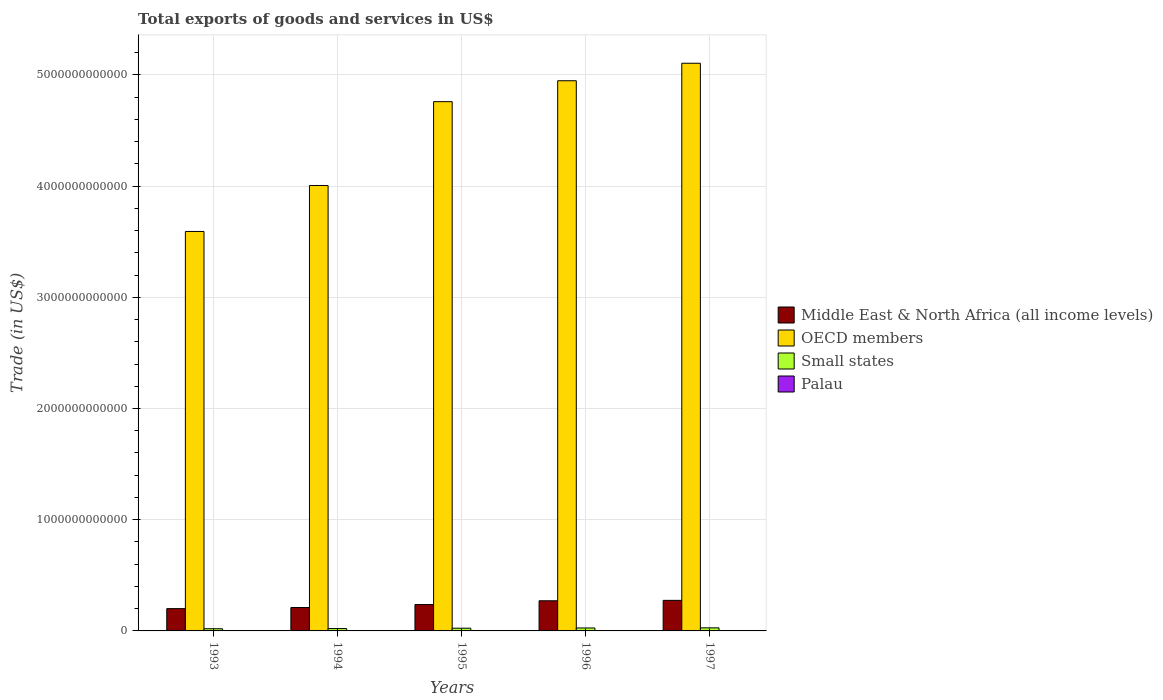How many different coloured bars are there?
Give a very brief answer. 4. How many groups of bars are there?
Your response must be concise. 5. Are the number of bars on each tick of the X-axis equal?
Ensure brevity in your answer.  Yes. How many bars are there on the 2nd tick from the left?
Keep it short and to the point. 4. How many bars are there on the 3rd tick from the right?
Keep it short and to the point. 4. What is the total exports of goods and services in Small states in 1995?
Your answer should be compact. 2.44e+1. Across all years, what is the maximum total exports of goods and services in OECD members?
Your answer should be compact. 5.10e+12. Across all years, what is the minimum total exports of goods and services in Small states?
Your response must be concise. 1.95e+1. In which year was the total exports of goods and services in Middle East & North Africa (all income levels) maximum?
Ensure brevity in your answer.  1997. In which year was the total exports of goods and services in Palau minimum?
Your answer should be very brief. 1997. What is the total total exports of goods and services in Middle East & North Africa (all income levels) in the graph?
Your answer should be compact. 1.19e+12. What is the difference between the total exports of goods and services in Middle East & North Africa (all income levels) in 1993 and that in 1997?
Give a very brief answer. -7.41e+1. What is the difference between the total exports of goods and services in Palau in 1993 and the total exports of goods and services in OECD members in 1997?
Your answer should be very brief. -5.10e+12. What is the average total exports of goods and services in OECD members per year?
Provide a short and direct response. 4.48e+12. In the year 1996, what is the difference between the total exports of goods and services in Palau and total exports of goods and services in Small states?
Provide a succinct answer. -2.64e+1. In how many years, is the total exports of goods and services in Small states greater than 3000000000000 US$?
Offer a very short reply. 0. What is the ratio of the total exports of goods and services in Middle East & North Africa (all income levels) in 1993 to that in 1997?
Keep it short and to the point. 0.73. Is the difference between the total exports of goods and services in Palau in 1994 and 1997 greater than the difference between the total exports of goods and services in Small states in 1994 and 1997?
Provide a succinct answer. Yes. What is the difference between the highest and the second highest total exports of goods and services in Middle East & North Africa (all income levels)?
Give a very brief answer. 3.57e+09. What is the difference between the highest and the lowest total exports of goods and services in Middle East & North Africa (all income levels)?
Give a very brief answer. 7.41e+1. What does the 3rd bar from the left in 1994 represents?
Keep it short and to the point. Small states. What does the 1st bar from the right in 1994 represents?
Your response must be concise. Palau. Is it the case that in every year, the sum of the total exports of goods and services in Palau and total exports of goods and services in OECD members is greater than the total exports of goods and services in Middle East & North Africa (all income levels)?
Make the answer very short. Yes. How many years are there in the graph?
Give a very brief answer. 5. What is the difference between two consecutive major ticks on the Y-axis?
Provide a succinct answer. 1.00e+12. Are the values on the major ticks of Y-axis written in scientific E-notation?
Your answer should be very brief. No. Does the graph contain any zero values?
Your answer should be very brief. No. Does the graph contain grids?
Your answer should be compact. Yes. How are the legend labels stacked?
Ensure brevity in your answer.  Vertical. What is the title of the graph?
Your answer should be compact. Total exports of goods and services in US$. What is the label or title of the X-axis?
Your answer should be very brief. Years. What is the label or title of the Y-axis?
Offer a very short reply. Trade (in US$). What is the Trade (in US$) of Middle East & North Africa (all income levels) in 1993?
Your response must be concise. 2.01e+11. What is the Trade (in US$) in OECD members in 1993?
Provide a succinct answer. 3.59e+12. What is the Trade (in US$) of Small states in 1993?
Offer a very short reply. 1.95e+1. What is the Trade (in US$) of Palau in 1993?
Your response must be concise. 1.77e+07. What is the Trade (in US$) of Middle East & North Africa (all income levels) in 1994?
Offer a terse response. 2.10e+11. What is the Trade (in US$) of OECD members in 1994?
Offer a very short reply. 4.00e+12. What is the Trade (in US$) in Small states in 1994?
Give a very brief answer. 2.12e+1. What is the Trade (in US$) in Palau in 1994?
Make the answer very short. 1.26e+07. What is the Trade (in US$) of Middle East & North Africa (all income levels) in 1995?
Offer a terse response. 2.37e+11. What is the Trade (in US$) of OECD members in 1995?
Provide a short and direct response. 4.76e+12. What is the Trade (in US$) in Small states in 1995?
Your response must be concise. 2.44e+1. What is the Trade (in US$) in Palau in 1995?
Your answer should be compact. 1.39e+07. What is the Trade (in US$) of Middle East & North Africa (all income levels) in 1996?
Provide a succinct answer. 2.71e+11. What is the Trade (in US$) of OECD members in 1996?
Keep it short and to the point. 4.95e+12. What is the Trade (in US$) of Small states in 1996?
Your answer should be very brief. 2.64e+1. What is the Trade (in US$) in Palau in 1996?
Offer a very short reply. 1.39e+07. What is the Trade (in US$) in Middle East & North Africa (all income levels) in 1997?
Offer a very short reply. 2.75e+11. What is the Trade (in US$) of OECD members in 1997?
Your answer should be very brief. 5.10e+12. What is the Trade (in US$) in Small states in 1997?
Your response must be concise. 2.76e+1. What is the Trade (in US$) of Palau in 1997?
Your answer should be very brief. 1.18e+07. Across all years, what is the maximum Trade (in US$) of Middle East & North Africa (all income levels)?
Provide a short and direct response. 2.75e+11. Across all years, what is the maximum Trade (in US$) in OECD members?
Give a very brief answer. 5.10e+12. Across all years, what is the maximum Trade (in US$) of Small states?
Provide a short and direct response. 2.76e+1. Across all years, what is the maximum Trade (in US$) of Palau?
Your answer should be compact. 1.77e+07. Across all years, what is the minimum Trade (in US$) of Middle East & North Africa (all income levels)?
Provide a short and direct response. 2.01e+11. Across all years, what is the minimum Trade (in US$) of OECD members?
Provide a succinct answer. 3.59e+12. Across all years, what is the minimum Trade (in US$) of Small states?
Give a very brief answer. 1.95e+1. Across all years, what is the minimum Trade (in US$) in Palau?
Provide a short and direct response. 1.18e+07. What is the total Trade (in US$) in Middle East & North Africa (all income levels) in the graph?
Offer a terse response. 1.19e+12. What is the total Trade (in US$) of OECD members in the graph?
Ensure brevity in your answer.  2.24e+13. What is the total Trade (in US$) in Small states in the graph?
Your answer should be very brief. 1.19e+11. What is the total Trade (in US$) in Palau in the graph?
Your response must be concise. 6.99e+07. What is the difference between the Trade (in US$) of Middle East & North Africa (all income levels) in 1993 and that in 1994?
Your response must be concise. -9.86e+09. What is the difference between the Trade (in US$) of OECD members in 1993 and that in 1994?
Give a very brief answer. -4.13e+11. What is the difference between the Trade (in US$) of Small states in 1993 and that in 1994?
Make the answer very short. -1.68e+09. What is the difference between the Trade (in US$) of Palau in 1993 and that in 1994?
Your answer should be compact. 5.10e+06. What is the difference between the Trade (in US$) of Middle East & North Africa (all income levels) in 1993 and that in 1995?
Provide a succinct answer. -3.65e+1. What is the difference between the Trade (in US$) in OECD members in 1993 and that in 1995?
Keep it short and to the point. -1.17e+12. What is the difference between the Trade (in US$) of Small states in 1993 and that in 1995?
Give a very brief answer. -4.92e+09. What is the difference between the Trade (in US$) in Palau in 1993 and that in 1995?
Make the answer very short. 3.83e+06. What is the difference between the Trade (in US$) of Middle East & North Africa (all income levels) in 1993 and that in 1996?
Ensure brevity in your answer.  -7.05e+1. What is the difference between the Trade (in US$) in OECD members in 1993 and that in 1996?
Your answer should be very brief. -1.36e+12. What is the difference between the Trade (in US$) of Small states in 1993 and that in 1996?
Keep it short and to the point. -6.89e+09. What is the difference between the Trade (in US$) of Palau in 1993 and that in 1996?
Your answer should be very brief. 3.79e+06. What is the difference between the Trade (in US$) in Middle East & North Africa (all income levels) in 1993 and that in 1997?
Offer a terse response. -7.41e+1. What is the difference between the Trade (in US$) of OECD members in 1993 and that in 1997?
Give a very brief answer. -1.51e+12. What is the difference between the Trade (in US$) of Small states in 1993 and that in 1997?
Your answer should be very brief. -8.12e+09. What is the difference between the Trade (in US$) in Palau in 1993 and that in 1997?
Keep it short and to the point. 5.89e+06. What is the difference between the Trade (in US$) of Middle East & North Africa (all income levels) in 1994 and that in 1995?
Keep it short and to the point. -2.66e+1. What is the difference between the Trade (in US$) of OECD members in 1994 and that in 1995?
Keep it short and to the point. -7.54e+11. What is the difference between the Trade (in US$) of Small states in 1994 and that in 1995?
Your answer should be very brief. -3.24e+09. What is the difference between the Trade (in US$) of Palau in 1994 and that in 1995?
Offer a terse response. -1.27e+06. What is the difference between the Trade (in US$) of Middle East & North Africa (all income levels) in 1994 and that in 1996?
Ensure brevity in your answer.  -6.07e+1. What is the difference between the Trade (in US$) in OECD members in 1994 and that in 1996?
Keep it short and to the point. -9.42e+11. What is the difference between the Trade (in US$) of Small states in 1994 and that in 1996?
Keep it short and to the point. -5.21e+09. What is the difference between the Trade (in US$) in Palau in 1994 and that in 1996?
Your answer should be compact. -1.31e+06. What is the difference between the Trade (in US$) in Middle East & North Africa (all income levels) in 1994 and that in 1997?
Make the answer very short. -6.42e+1. What is the difference between the Trade (in US$) of OECD members in 1994 and that in 1997?
Ensure brevity in your answer.  -1.10e+12. What is the difference between the Trade (in US$) of Small states in 1994 and that in 1997?
Provide a short and direct response. -6.44e+09. What is the difference between the Trade (in US$) in Palau in 1994 and that in 1997?
Offer a terse response. 7.88e+05. What is the difference between the Trade (in US$) of Middle East & North Africa (all income levels) in 1995 and that in 1996?
Make the answer very short. -3.40e+1. What is the difference between the Trade (in US$) in OECD members in 1995 and that in 1996?
Give a very brief answer. -1.88e+11. What is the difference between the Trade (in US$) in Small states in 1995 and that in 1996?
Your answer should be very brief. -1.97e+09. What is the difference between the Trade (in US$) of Palau in 1995 and that in 1996?
Offer a terse response. -3.90e+04. What is the difference between the Trade (in US$) of Middle East & North Africa (all income levels) in 1995 and that in 1997?
Ensure brevity in your answer.  -3.76e+1. What is the difference between the Trade (in US$) of OECD members in 1995 and that in 1997?
Ensure brevity in your answer.  -3.45e+11. What is the difference between the Trade (in US$) in Small states in 1995 and that in 1997?
Provide a succinct answer. -3.19e+09. What is the difference between the Trade (in US$) of Palau in 1995 and that in 1997?
Your answer should be compact. 2.06e+06. What is the difference between the Trade (in US$) of Middle East & North Africa (all income levels) in 1996 and that in 1997?
Keep it short and to the point. -3.57e+09. What is the difference between the Trade (in US$) in OECD members in 1996 and that in 1997?
Ensure brevity in your answer.  -1.57e+11. What is the difference between the Trade (in US$) of Small states in 1996 and that in 1997?
Keep it short and to the point. -1.23e+09. What is the difference between the Trade (in US$) in Palau in 1996 and that in 1997?
Your answer should be compact. 2.10e+06. What is the difference between the Trade (in US$) in Middle East & North Africa (all income levels) in 1993 and the Trade (in US$) in OECD members in 1994?
Give a very brief answer. -3.80e+12. What is the difference between the Trade (in US$) of Middle East & North Africa (all income levels) in 1993 and the Trade (in US$) of Small states in 1994?
Keep it short and to the point. 1.79e+11. What is the difference between the Trade (in US$) of Middle East & North Africa (all income levels) in 1993 and the Trade (in US$) of Palau in 1994?
Your response must be concise. 2.01e+11. What is the difference between the Trade (in US$) in OECD members in 1993 and the Trade (in US$) in Small states in 1994?
Make the answer very short. 3.57e+12. What is the difference between the Trade (in US$) in OECD members in 1993 and the Trade (in US$) in Palau in 1994?
Ensure brevity in your answer.  3.59e+12. What is the difference between the Trade (in US$) in Small states in 1993 and the Trade (in US$) in Palau in 1994?
Provide a succinct answer. 1.95e+1. What is the difference between the Trade (in US$) in Middle East & North Africa (all income levels) in 1993 and the Trade (in US$) in OECD members in 1995?
Your answer should be compact. -4.56e+12. What is the difference between the Trade (in US$) of Middle East & North Africa (all income levels) in 1993 and the Trade (in US$) of Small states in 1995?
Your answer should be very brief. 1.76e+11. What is the difference between the Trade (in US$) of Middle East & North Africa (all income levels) in 1993 and the Trade (in US$) of Palau in 1995?
Make the answer very short. 2.01e+11. What is the difference between the Trade (in US$) of OECD members in 1993 and the Trade (in US$) of Small states in 1995?
Your answer should be very brief. 3.57e+12. What is the difference between the Trade (in US$) in OECD members in 1993 and the Trade (in US$) in Palau in 1995?
Offer a very short reply. 3.59e+12. What is the difference between the Trade (in US$) of Small states in 1993 and the Trade (in US$) of Palau in 1995?
Make the answer very short. 1.95e+1. What is the difference between the Trade (in US$) in Middle East & North Africa (all income levels) in 1993 and the Trade (in US$) in OECD members in 1996?
Offer a very short reply. -4.75e+12. What is the difference between the Trade (in US$) in Middle East & North Africa (all income levels) in 1993 and the Trade (in US$) in Small states in 1996?
Offer a terse response. 1.74e+11. What is the difference between the Trade (in US$) in Middle East & North Africa (all income levels) in 1993 and the Trade (in US$) in Palau in 1996?
Offer a terse response. 2.01e+11. What is the difference between the Trade (in US$) of OECD members in 1993 and the Trade (in US$) of Small states in 1996?
Offer a very short reply. 3.57e+12. What is the difference between the Trade (in US$) of OECD members in 1993 and the Trade (in US$) of Palau in 1996?
Give a very brief answer. 3.59e+12. What is the difference between the Trade (in US$) of Small states in 1993 and the Trade (in US$) of Palau in 1996?
Offer a very short reply. 1.95e+1. What is the difference between the Trade (in US$) in Middle East & North Africa (all income levels) in 1993 and the Trade (in US$) in OECD members in 1997?
Your answer should be very brief. -4.90e+12. What is the difference between the Trade (in US$) of Middle East & North Africa (all income levels) in 1993 and the Trade (in US$) of Small states in 1997?
Your response must be concise. 1.73e+11. What is the difference between the Trade (in US$) of Middle East & North Africa (all income levels) in 1993 and the Trade (in US$) of Palau in 1997?
Ensure brevity in your answer.  2.01e+11. What is the difference between the Trade (in US$) in OECD members in 1993 and the Trade (in US$) in Small states in 1997?
Offer a very short reply. 3.56e+12. What is the difference between the Trade (in US$) in OECD members in 1993 and the Trade (in US$) in Palau in 1997?
Ensure brevity in your answer.  3.59e+12. What is the difference between the Trade (in US$) in Small states in 1993 and the Trade (in US$) in Palau in 1997?
Offer a very short reply. 1.95e+1. What is the difference between the Trade (in US$) in Middle East & North Africa (all income levels) in 1994 and the Trade (in US$) in OECD members in 1995?
Your answer should be very brief. -4.55e+12. What is the difference between the Trade (in US$) of Middle East & North Africa (all income levels) in 1994 and the Trade (in US$) of Small states in 1995?
Offer a terse response. 1.86e+11. What is the difference between the Trade (in US$) of Middle East & North Africa (all income levels) in 1994 and the Trade (in US$) of Palau in 1995?
Your answer should be very brief. 2.10e+11. What is the difference between the Trade (in US$) in OECD members in 1994 and the Trade (in US$) in Small states in 1995?
Your response must be concise. 3.98e+12. What is the difference between the Trade (in US$) of OECD members in 1994 and the Trade (in US$) of Palau in 1995?
Provide a succinct answer. 4.00e+12. What is the difference between the Trade (in US$) of Small states in 1994 and the Trade (in US$) of Palau in 1995?
Offer a terse response. 2.12e+1. What is the difference between the Trade (in US$) in Middle East & North Africa (all income levels) in 1994 and the Trade (in US$) in OECD members in 1996?
Make the answer very short. -4.74e+12. What is the difference between the Trade (in US$) of Middle East & North Africa (all income levels) in 1994 and the Trade (in US$) of Small states in 1996?
Keep it short and to the point. 1.84e+11. What is the difference between the Trade (in US$) of Middle East & North Africa (all income levels) in 1994 and the Trade (in US$) of Palau in 1996?
Make the answer very short. 2.10e+11. What is the difference between the Trade (in US$) in OECD members in 1994 and the Trade (in US$) in Small states in 1996?
Provide a succinct answer. 3.98e+12. What is the difference between the Trade (in US$) of OECD members in 1994 and the Trade (in US$) of Palau in 1996?
Provide a succinct answer. 4.00e+12. What is the difference between the Trade (in US$) in Small states in 1994 and the Trade (in US$) in Palau in 1996?
Offer a terse response. 2.12e+1. What is the difference between the Trade (in US$) in Middle East & North Africa (all income levels) in 1994 and the Trade (in US$) in OECD members in 1997?
Make the answer very short. -4.89e+12. What is the difference between the Trade (in US$) in Middle East & North Africa (all income levels) in 1994 and the Trade (in US$) in Small states in 1997?
Make the answer very short. 1.83e+11. What is the difference between the Trade (in US$) of Middle East & North Africa (all income levels) in 1994 and the Trade (in US$) of Palau in 1997?
Ensure brevity in your answer.  2.10e+11. What is the difference between the Trade (in US$) in OECD members in 1994 and the Trade (in US$) in Small states in 1997?
Make the answer very short. 3.98e+12. What is the difference between the Trade (in US$) of OECD members in 1994 and the Trade (in US$) of Palau in 1997?
Your response must be concise. 4.00e+12. What is the difference between the Trade (in US$) of Small states in 1994 and the Trade (in US$) of Palau in 1997?
Provide a short and direct response. 2.12e+1. What is the difference between the Trade (in US$) of Middle East & North Africa (all income levels) in 1995 and the Trade (in US$) of OECD members in 1996?
Provide a short and direct response. -4.71e+12. What is the difference between the Trade (in US$) of Middle East & North Africa (all income levels) in 1995 and the Trade (in US$) of Small states in 1996?
Offer a very short reply. 2.11e+11. What is the difference between the Trade (in US$) in Middle East & North Africa (all income levels) in 1995 and the Trade (in US$) in Palau in 1996?
Offer a terse response. 2.37e+11. What is the difference between the Trade (in US$) of OECD members in 1995 and the Trade (in US$) of Small states in 1996?
Provide a short and direct response. 4.73e+12. What is the difference between the Trade (in US$) in OECD members in 1995 and the Trade (in US$) in Palau in 1996?
Keep it short and to the point. 4.76e+12. What is the difference between the Trade (in US$) in Small states in 1995 and the Trade (in US$) in Palau in 1996?
Your answer should be very brief. 2.44e+1. What is the difference between the Trade (in US$) in Middle East & North Africa (all income levels) in 1995 and the Trade (in US$) in OECD members in 1997?
Provide a short and direct response. -4.87e+12. What is the difference between the Trade (in US$) of Middle East & North Africa (all income levels) in 1995 and the Trade (in US$) of Small states in 1997?
Your answer should be very brief. 2.09e+11. What is the difference between the Trade (in US$) in Middle East & North Africa (all income levels) in 1995 and the Trade (in US$) in Palau in 1997?
Offer a terse response. 2.37e+11. What is the difference between the Trade (in US$) of OECD members in 1995 and the Trade (in US$) of Small states in 1997?
Your response must be concise. 4.73e+12. What is the difference between the Trade (in US$) of OECD members in 1995 and the Trade (in US$) of Palau in 1997?
Offer a terse response. 4.76e+12. What is the difference between the Trade (in US$) of Small states in 1995 and the Trade (in US$) of Palau in 1997?
Provide a succinct answer. 2.44e+1. What is the difference between the Trade (in US$) in Middle East & North Africa (all income levels) in 1996 and the Trade (in US$) in OECD members in 1997?
Your answer should be very brief. -4.83e+12. What is the difference between the Trade (in US$) in Middle East & North Africa (all income levels) in 1996 and the Trade (in US$) in Small states in 1997?
Your answer should be very brief. 2.43e+11. What is the difference between the Trade (in US$) of Middle East & North Africa (all income levels) in 1996 and the Trade (in US$) of Palau in 1997?
Ensure brevity in your answer.  2.71e+11. What is the difference between the Trade (in US$) in OECD members in 1996 and the Trade (in US$) in Small states in 1997?
Keep it short and to the point. 4.92e+12. What is the difference between the Trade (in US$) of OECD members in 1996 and the Trade (in US$) of Palau in 1997?
Your answer should be very brief. 4.95e+12. What is the difference between the Trade (in US$) in Small states in 1996 and the Trade (in US$) in Palau in 1997?
Your answer should be very brief. 2.64e+1. What is the average Trade (in US$) in Middle East & North Africa (all income levels) per year?
Ensure brevity in your answer.  2.39e+11. What is the average Trade (in US$) of OECD members per year?
Offer a terse response. 4.48e+12. What is the average Trade (in US$) in Small states per year?
Keep it short and to the point. 2.38e+1. What is the average Trade (in US$) of Palau per year?
Make the answer very short. 1.40e+07. In the year 1993, what is the difference between the Trade (in US$) of Middle East & North Africa (all income levels) and Trade (in US$) of OECD members?
Offer a very short reply. -3.39e+12. In the year 1993, what is the difference between the Trade (in US$) in Middle East & North Africa (all income levels) and Trade (in US$) in Small states?
Ensure brevity in your answer.  1.81e+11. In the year 1993, what is the difference between the Trade (in US$) in Middle East & North Africa (all income levels) and Trade (in US$) in Palau?
Your answer should be compact. 2.01e+11. In the year 1993, what is the difference between the Trade (in US$) in OECD members and Trade (in US$) in Small states?
Make the answer very short. 3.57e+12. In the year 1993, what is the difference between the Trade (in US$) in OECD members and Trade (in US$) in Palau?
Provide a short and direct response. 3.59e+12. In the year 1993, what is the difference between the Trade (in US$) in Small states and Trade (in US$) in Palau?
Make the answer very short. 1.95e+1. In the year 1994, what is the difference between the Trade (in US$) in Middle East & North Africa (all income levels) and Trade (in US$) in OECD members?
Offer a very short reply. -3.79e+12. In the year 1994, what is the difference between the Trade (in US$) of Middle East & North Africa (all income levels) and Trade (in US$) of Small states?
Provide a succinct answer. 1.89e+11. In the year 1994, what is the difference between the Trade (in US$) of Middle East & North Africa (all income levels) and Trade (in US$) of Palau?
Your answer should be very brief. 2.10e+11. In the year 1994, what is the difference between the Trade (in US$) of OECD members and Trade (in US$) of Small states?
Make the answer very short. 3.98e+12. In the year 1994, what is the difference between the Trade (in US$) of OECD members and Trade (in US$) of Palau?
Give a very brief answer. 4.00e+12. In the year 1994, what is the difference between the Trade (in US$) in Small states and Trade (in US$) in Palau?
Your answer should be very brief. 2.12e+1. In the year 1995, what is the difference between the Trade (in US$) in Middle East & North Africa (all income levels) and Trade (in US$) in OECD members?
Give a very brief answer. -4.52e+12. In the year 1995, what is the difference between the Trade (in US$) of Middle East & North Africa (all income levels) and Trade (in US$) of Small states?
Offer a very short reply. 2.13e+11. In the year 1995, what is the difference between the Trade (in US$) in Middle East & North Africa (all income levels) and Trade (in US$) in Palau?
Your answer should be very brief. 2.37e+11. In the year 1995, what is the difference between the Trade (in US$) of OECD members and Trade (in US$) of Small states?
Your answer should be very brief. 4.73e+12. In the year 1995, what is the difference between the Trade (in US$) of OECD members and Trade (in US$) of Palau?
Offer a terse response. 4.76e+12. In the year 1995, what is the difference between the Trade (in US$) of Small states and Trade (in US$) of Palau?
Offer a very short reply. 2.44e+1. In the year 1996, what is the difference between the Trade (in US$) in Middle East & North Africa (all income levels) and Trade (in US$) in OECD members?
Ensure brevity in your answer.  -4.68e+12. In the year 1996, what is the difference between the Trade (in US$) of Middle East & North Africa (all income levels) and Trade (in US$) of Small states?
Keep it short and to the point. 2.45e+11. In the year 1996, what is the difference between the Trade (in US$) of Middle East & North Africa (all income levels) and Trade (in US$) of Palau?
Your answer should be compact. 2.71e+11. In the year 1996, what is the difference between the Trade (in US$) of OECD members and Trade (in US$) of Small states?
Offer a terse response. 4.92e+12. In the year 1996, what is the difference between the Trade (in US$) in OECD members and Trade (in US$) in Palau?
Provide a succinct answer. 4.95e+12. In the year 1996, what is the difference between the Trade (in US$) of Small states and Trade (in US$) of Palau?
Ensure brevity in your answer.  2.64e+1. In the year 1997, what is the difference between the Trade (in US$) in Middle East & North Africa (all income levels) and Trade (in US$) in OECD members?
Provide a short and direct response. -4.83e+12. In the year 1997, what is the difference between the Trade (in US$) of Middle East & North Africa (all income levels) and Trade (in US$) of Small states?
Your answer should be very brief. 2.47e+11. In the year 1997, what is the difference between the Trade (in US$) of Middle East & North Africa (all income levels) and Trade (in US$) of Palau?
Offer a terse response. 2.75e+11. In the year 1997, what is the difference between the Trade (in US$) in OECD members and Trade (in US$) in Small states?
Ensure brevity in your answer.  5.08e+12. In the year 1997, what is the difference between the Trade (in US$) of OECD members and Trade (in US$) of Palau?
Your response must be concise. 5.10e+12. In the year 1997, what is the difference between the Trade (in US$) of Small states and Trade (in US$) of Palau?
Ensure brevity in your answer.  2.76e+1. What is the ratio of the Trade (in US$) in Middle East & North Africa (all income levels) in 1993 to that in 1994?
Your answer should be very brief. 0.95. What is the ratio of the Trade (in US$) of OECD members in 1993 to that in 1994?
Ensure brevity in your answer.  0.9. What is the ratio of the Trade (in US$) of Small states in 1993 to that in 1994?
Ensure brevity in your answer.  0.92. What is the ratio of the Trade (in US$) of Palau in 1993 to that in 1994?
Keep it short and to the point. 1.4. What is the ratio of the Trade (in US$) in Middle East & North Africa (all income levels) in 1993 to that in 1995?
Keep it short and to the point. 0.85. What is the ratio of the Trade (in US$) of OECD members in 1993 to that in 1995?
Your answer should be compact. 0.75. What is the ratio of the Trade (in US$) in Small states in 1993 to that in 1995?
Give a very brief answer. 0.8. What is the ratio of the Trade (in US$) of Palau in 1993 to that in 1995?
Give a very brief answer. 1.28. What is the ratio of the Trade (in US$) in Middle East & North Africa (all income levels) in 1993 to that in 1996?
Make the answer very short. 0.74. What is the ratio of the Trade (in US$) in OECD members in 1993 to that in 1996?
Offer a terse response. 0.73. What is the ratio of the Trade (in US$) in Small states in 1993 to that in 1996?
Your answer should be very brief. 0.74. What is the ratio of the Trade (in US$) of Palau in 1993 to that in 1996?
Keep it short and to the point. 1.27. What is the ratio of the Trade (in US$) of Middle East & North Africa (all income levels) in 1993 to that in 1997?
Give a very brief answer. 0.73. What is the ratio of the Trade (in US$) of OECD members in 1993 to that in 1997?
Offer a terse response. 0.7. What is the ratio of the Trade (in US$) in Small states in 1993 to that in 1997?
Your answer should be very brief. 0.71. What is the ratio of the Trade (in US$) in Palau in 1993 to that in 1997?
Provide a succinct answer. 1.5. What is the ratio of the Trade (in US$) in Middle East & North Africa (all income levels) in 1994 to that in 1995?
Keep it short and to the point. 0.89. What is the ratio of the Trade (in US$) in OECD members in 1994 to that in 1995?
Make the answer very short. 0.84. What is the ratio of the Trade (in US$) of Small states in 1994 to that in 1995?
Provide a short and direct response. 0.87. What is the ratio of the Trade (in US$) in Palau in 1994 to that in 1995?
Make the answer very short. 0.91. What is the ratio of the Trade (in US$) in Middle East & North Africa (all income levels) in 1994 to that in 1996?
Make the answer very short. 0.78. What is the ratio of the Trade (in US$) of OECD members in 1994 to that in 1996?
Offer a very short reply. 0.81. What is the ratio of the Trade (in US$) of Small states in 1994 to that in 1996?
Offer a very short reply. 0.8. What is the ratio of the Trade (in US$) of Palau in 1994 to that in 1996?
Your answer should be compact. 0.91. What is the ratio of the Trade (in US$) of Middle East & North Africa (all income levels) in 1994 to that in 1997?
Your answer should be very brief. 0.77. What is the ratio of the Trade (in US$) in OECD members in 1994 to that in 1997?
Make the answer very short. 0.78. What is the ratio of the Trade (in US$) of Small states in 1994 to that in 1997?
Make the answer very short. 0.77. What is the ratio of the Trade (in US$) in Palau in 1994 to that in 1997?
Your response must be concise. 1.07. What is the ratio of the Trade (in US$) of Middle East & North Africa (all income levels) in 1995 to that in 1996?
Provide a succinct answer. 0.87. What is the ratio of the Trade (in US$) in Small states in 1995 to that in 1996?
Your answer should be very brief. 0.93. What is the ratio of the Trade (in US$) in Palau in 1995 to that in 1996?
Keep it short and to the point. 1. What is the ratio of the Trade (in US$) in Middle East & North Africa (all income levels) in 1995 to that in 1997?
Provide a succinct answer. 0.86. What is the ratio of the Trade (in US$) in OECD members in 1995 to that in 1997?
Keep it short and to the point. 0.93. What is the ratio of the Trade (in US$) in Small states in 1995 to that in 1997?
Give a very brief answer. 0.88. What is the ratio of the Trade (in US$) in Palau in 1995 to that in 1997?
Your answer should be compact. 1.17. What is the ratio of the Trade (in US$) in Middle East & North Africa (all income levels) in 1996 to that in 1997?
Provide a succinct answer. 0.99. What is the ratio of the Trade (in US$) of OECD members in 1996 to that in 1997?
Ensure brevity in your answer.  0.97. What is the ratio of the Trade (in US$) of Small states in 1996 to that in 1997?
Give a very brief answer. 0.96. What is the ratio of the Trade (in US$) of Palau in 1996 to that in 1997?
Your answer should be very brief. 1.18. What is the difference between the highest and the second highest Trade (in US$) in Middle East & North Africa (all income levels)?
Offer a very short reply. 3.57e+09. What is the difference between the highest and the second highest Trade (in US$) in OECD members?
Make the answer very short. 1.57e+11. What is the difference between the highest and the second highest Trade (in US$) in Small states?
Offer a very short reply. 1.23e+09. What is the difference between the highest and the second highest Trade (in US$) of Palau?
Your response must be concise. 3.79e+06. What is the difference between the highest and the lowest Trade (in US$) in Middle East & North Africa (all income levels)?
Make the answer very short. 7.41e+1. What is the difference between the highest and the lowest Trade (in US$) of OECD members?
Offer a very short reply. 1.51e+12. What is the difference between the highest and the lowest Trade (in US$) in Small states?
Your answer should be very brief. 8.12e+09. What is the difference between the highest and the lowest Trade (in US$) of Palau?
Your response must be concise. 5.89e+06. 